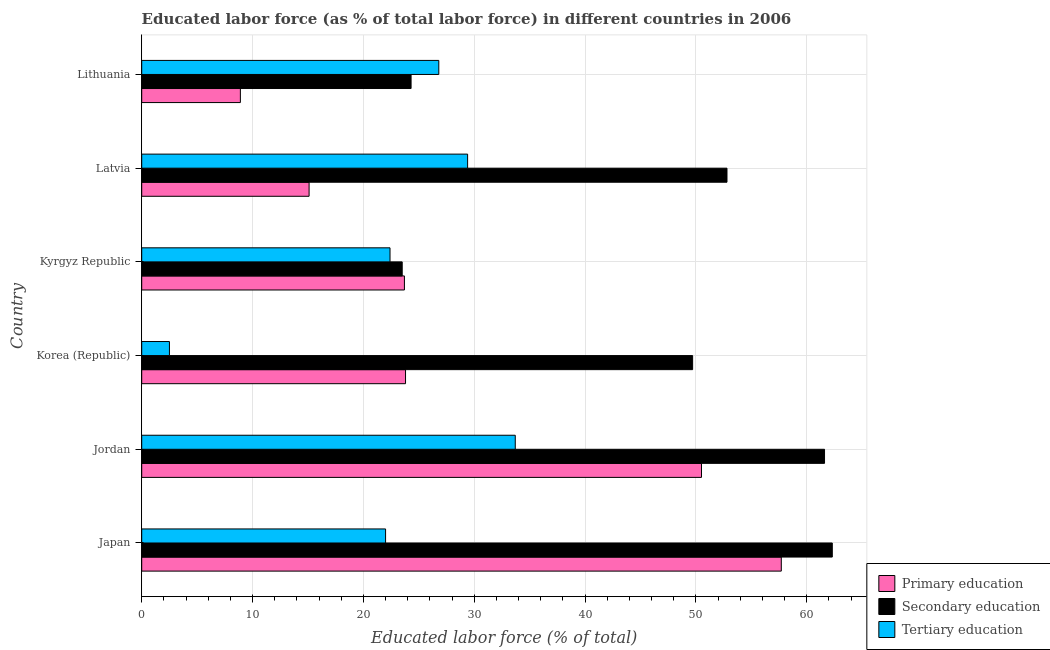How many groups of bars are there?
Make the answer very short. 6. Are the number of bars per tick equal to the number of legend labels?
Offer a very short reply. Yes. What is the percentage of labor force who received primary education in Japan?
Provide a short and direct response. 57.7. Across all countries, what is the maximum percentage of labor force who received secondary education?
Provide a short and direct response. 62.3. In which country was the percentage of labor force who received tertiary education maximum?
Provide a succinct answer. Jordan. In which country was the percentage of labor force who received tertiary education minimum?
Give a very brief answer. Korea (Republic). What is the total percentage of labor force who received primary education in the graph?
Keep it short and to the point. 179.7. What is the difference between the percentage of labor force who received secondary education in Japan and that in Kyrgyz Republic?
Give a very brief answer. 38.8. What is the difference between the percentage of labor force who received tertiary education in Kyrgyz Republic and the percentage of labor force who received primary education in Lithuania?
Offer a very short reply. 13.5. What is the average percentage of labor force who received primary education per country?
Your answer should be compact. 29.95. What is the difference between the percentage of labor force who received tertiary education and percentage of labor force who received primary education in Jordan?
Ensure brevity in your answer.  -16.8. In how many countries, is the percentage of labor force who received primary education greater than 42 %?
Provide a succinct answer. 2. What is the ratio of the percentage of labor force who received tertiary education in Kyrgyz Republic to that in Latvia?
Offer a terse response. 0.76. What is the difference between the highest and the lowest percentage of labor force who received secondary education?
Make the answer very short. 38.8. In how many countries, is the percentage of labor force who received tertiary education greater than the average percentage of labor force who received tertiary education taken over all countries?
Your answer should be very brief. 3. Is the sum of the percentage of labor force who received secondary education in Japan and Korea (Republic) greater than the maximum percentage of labor force who received tertiary education across all countries?
Offer a very short reply. Yes. What does the 2nd bar from the top in Kyrgyz Republic represents?
Keep it short and to the point. Secondary education. What does the 1st bar from the bottom in Japan represents?
Give a very brief answer. Primary education. Is it the case that in every country, the sum of the percentage of labor force who received primary education and percentage of labor force who received secondary education is greater than the percentage of labor force who received tertiary education?
Provide a succinct answer. Yes. How many bars are there?
Make the answer very short. 18. Are all the bars in the graph horizontal?
Make the answer very short. Yes. How many countries are there in the graph?
Provide a succinct answer. 6. What is the difference between two consecutive major ticks on the X-axis?
Offer a terse response. 10. Are the values on the major ticks of X-axis written in scientific E-notation?
Your response must be concise. No. How many legend labels are there?
Offer a very short reply. 3. What is the title of the graph?
Offer a terse response. Educated labor force (as % of total labor force) in different countries in 2006. Does "Agriculture" appear as one of the legend labels in the graph?
Your answer should be compact. No. What is the label or title of the X-axis?
Offer a terse response. Educated labor force (% of total). What is the label or title of the Y-axis?
Offer a terse response. Country. What is the Educated labor force (% of total) of Primary education in Japan?
Provide a short and direct response. 57.7. What is the Educated labor force (% of total) in Secondary education in Japan?
Ensure brevity in your answer.  62.3. What is the Educated labor force (% of total) of Tertiary education in Japan?
Provide a short and direct response. 22. What is the Educated labor force (% of total) in Primary education in Jordan?
Your response must be concise. 50.5. What is the Educated labor force (% of total) in Secondary education in Jordan?
Keep it short and to the point. 61.6. What is the Educated labor force (% of total) in Tertiary education in Jordan?
Your answer should be compact. 33.7. What is the Educated labor force (% of total) of Primary education in Korea (Republic)?
Your response must be concise. 23.8. What is the Educated labor force (% of total) of Secondary education in Korea (Republic)?
Make the answer very short. 49.7. What is the Educated labor force (% of total) of Primary education in Kyrgyz Republic?
Keep it short and to the point. 23.7. What is the Educated labor force (% of total) in Secondary education in Kyrgyz Republic?
Offer a very short reply. 23.5. What is the Educated labor force (% of total) in Tertiary education in Kyrgyz Republic?
Give a very brief answer. 22.4. What is the Educated labor force (% of total) in Primary education in Latvia?
Provide a short and direct response. 15.1. What is the Educated labor force (% of total) of Secondary education in Latvia?
Provide a short and direct response. 52.8. What is the Educated labor force (% of total) in Tertiary education in Latvia?
Your answer should be compact. 29.4. What is the Educated labor force (% of total) in Primary education in Lithuania?
Give a very brief answer. 8.9. What is the Educated labor force (% of total) of Secondary education in Lithuania?
Your answer should be compact. 24.3. What is the Educated labor force (% of total) in Tertiary education in Lithuania?
Your answer should be very brief. 26.8. Across all countries, what is the maximum Educated labor force (% of total) of Primary education?
Your answer should be very brief. 57.7. Across all countries, what is the maximum Educated labor force (% of total) in Secondary education?
Make the answer very short. 62.3. Across all countries, what is the maximum Educated labor force (% of total) in Tertiary education?
Your answer should be very brief. 33.7. Across all countries, what is the minimum Educated labor force (% of total) in Primary education?
Your answer should be compact. 8.9. Across all countries, what is the minimum Educated labor force (% of total) of Secondary education?
Offer a very short reply. 23.5. What is the total Educated labor force (% of total) in Primary education in the graph?
Give a very brief answer. 179.7. What is the total Educated labor force (% of total) of Secondary education in the graph?
Make the answer very short. 274.2. What is the total Educated labor force (% of total) in Tertiary education in the graph?
Your response must be concise. 136.8. What is the difference between the Educated labor force (% of total) of Primary education in Japan and that in Korea (Republic)?
Ensure brevity in your answer.  33.9. What is the difference between the Educated labor force (% of total) in Secondary education in Japan and that in Kyrgyz Republic?
Your answer should be very brief. 38.8. What is the difference between the Educated labor force (% of total) in Primary education in Japan and that in Latvia?
Keep it short and to the point. 42.6. What is the difference between the Educated labor force (% of total) of Tertiary education in Japan and that in Latvia?
Your answer should be compact. -7.4. What is the difference between the Educated labor force (% of total) in Primary education in Japan and that in Lithuania?
Offer a very short reply. 48.8. What is the difference between the Educated labor force (% of total) of Secondary education in Japan and that in Lithuania?
Give a very brief answer. 38. What is the difference between the Educated labor force (% of total) in Primary education in Jordan and that in Korea (Republic)?
Your response must be concise. 26.7. What is the difference between the Educated labor force (% of total) in Secondary education in Jordan and that in Korea (Republic)?
Make the answer very short. 11.9. What is the difference between the Educated labor force (% of total) in Tertiary education in Jordan and that in Korea (Republic)?
Ensure brevity in your answer.  31.2. What is the difference between the Educated labor force (% of total) of Primary education in Jordan and that in Kyrgyz Republic?
Keep it short and to the point. 26.8. What is the difference between the Educated labor force (% of total) in Secondary education in Jordan and that in Kyrgyz Republic?
Keep it short and to the point. 38.1. What is the difference between the Educated labor force (% of total) in Primary education in Jordan and that in Latvia?
Give a very brief answer. 35.4. What is the difference between the Educated labor force (% of total) of Tertiary education in Jordan and that in Latvia?
Give a very brief answer. 4.3. What is the difference between the Educated labor force (% of total) in Primary education in Jordan and that in Lithuania?
Offer a terse response. 41.6. What is the difference between the Educated labor force (% of total) in Secondary education in Jordan and that in Lithuania?
Your answer should be very brief. 37.3. What is the difference between the Educated labor force (% of total) in Tertiary education in Jordan and that in Lithuania?
Your answer should be very brief. 6.9. What is the difference between the Educated labor force (% of total) in Primary education in Korea (Republic) and that in Kyrgyz Republic?
Give a very brief answer. 0.1. What is the difference between the Educated labor force (% of total) in Secondary education in Korea (Republic) and that in Kyrgyz Republic?
Provide a succinct answer. 26.2. What is the difference between the Educated labor force (% of total) of Tertiary education in Korea (Republic) and that in Kyrgyz Republic?
Offer a terse response. -19.9. What is the difference between the Educated labor force (% of total) of Primary education in Korea (Republic) and that in Latvia?
Make the answer very short. 8.7. What is the difference between the Educated labor force (% of total) of Secondary education in Korea (Republic) and that in Latvia?
Your answer should be very brief. -3.1. What is the difference between the Educated labor force (% of total) of Tertiary education in Korea (Republic) and that in Latvia?
Provide a short and direct response. -26.9. What is the difference between the Educated labor force (% of total) in Primary education in Korea (Republic) and that in Lithuania?
Your answer should be compact. 14.9. What is the difference between the Educated labor force (% of total) in Secondary education in Korea (Republic) and that in Lithuania?
Provide a succinct answer. 25.4. What is the difference between the Educated labor force (% of total) in Tertiary education in Korea (Republic) and that in Lithuania?
Keep it short and to the point. -24.3. What is the difference between the Educated labor force (% of total) in Secondary education in Kyrgyz Republic and that in Latvia?
Your answer should be very brief. -29.3. What is the difference between the Educated labor force (% of total) in Tertiary education in Kyrgyz Republic and that in Lithuania?
Make the answer very short. -4.4. What is the difference between the Educated labor force (% of total) of Primary education in Latvia and that in Lithuania?
Provide a short and direct response. 6.2. What is the difference between the Educated labor force (% of total) in Primary education in Japan and the Educated labor force (% of total) in Secondary education in Jordan?
Provide a succinct answer. -3.9. What is the difference between the Educated labor force (% of total) in Secondary education in Japan and the Educated labor force (% of total) in Tertiary education in Jordan?
Ensure brevity in your answer.  28.6. What is the difference between the Educated labor force (% of total) in Primary education in Japan and the Educated labor force (% of total) in Tertiary education in Korea (Republic)?
Offer a very short reply. 55.2. What is the difference between the Educated labor force (% of total) of Secondary education in Japan and the Educated labor force (% of total) of Tertiary education in Korea (Republic)?
Provide a short and direct response. 59.8. What is the difference between the Educated labor force (% of total) in Primary education in Japan and the Educated labor force (% of total) in Secondary education in Kyrgyz Republic?
Your answer should be compact. 34.2. What is the difference between the Educated labor force (% of total) of Primary education in Japan and the Educated labor force (% of total) of Tertiary education in Kyrgyz Republic?
Offer a very short reply. 35.3. What is the difference between the Educated labor force (% of total) in Secondary education in Japan and the Educated labor force (% of total) in Tertiary education in Kyrgyz Republic?
Give a very brief answer. 39.9. What is the difference between the Educated labor force (% of total) of Primary education in Japan and the Educated labor force (% of total) of Tertiary education in Latvia?
Ensure brevity in your answer.  28.3. What is the difference between the Educated labor force (% of total) in Secondary education in Japan and the Educated labor force (% of total) in Tertiary education in Latvia?
Make the answer very short. 32.9. What is the difference between the Educated labor force (% of total) of Primary education in Japan and the Educated labor force (% of total) of Secondary education in Lithuania?
Offer a terse response. 33.4. What is the difference between the Educated labor force (% of total) of Primary education in Japan and the Educated labor force (% of total) of Tertiary education in Lithuania?
Keep it short and to the point. 30.9. What is the difference between the Educated labor force (% of total) of Secondary education in Japan and the Educated labor force (% of total) of Tertiary education in Lithuania?
Offer a terse response. 35.5. What is the difference between the Educated labor force (% of total) in Primary education in Jordan and the Educated labor force (% of total) in Tertiary education in Korea (Republic)?
Ensure brevity in your answer.  48. What is the difference between the Educated labor force (% of total) in Secondary education in Jordan and the Educated labor force (% of total) in Tertiary education in Korea (Republic)?
Provide a succinct answer. 59.1. What is the difference between the Educated labor force (% of total) in Primary education in Jordan and the Educated labor force (% of total) in Secondary education in Kyrgyz Republic?
Provide a succinct answer. 27. What is the difference between the Educated labor force (% of total) in Primary education in Jordan and the Educated labor force (% of total) in Tertiary education in Kyrgyz Republic?
Make the answer very short. 28.1. What is the difference between the Educated labor force (% of total) in Secondary education in Jordan and the Educated labor force (% of total) in Tertiary education in Kyrgyz Republic?
Provide a short and direct response. 39.2. What is the difference between the Educated labor force (% of total) of Primary education in Jordan and the Educated labor force (% of total) of Tertiary education in Latvia?
Offer a terse response. 21.1. What is the difference between the Educated labor force (% of total) of Secondary education in Jordan and the Educated labor force (% of total) of Tertiary education in Latvia?
Offer a very short reply. 32.2. What is the difference between the Educated labor force (% of total) of Primary education in Jordan and the Educated labor force (% of total) of Secondary education in Lithuania?
Keep it short and to the point. 26.2. What is the difference between the Educated labor force (% of total) in Primary education in Jordan and the Educated labor force (% of total) in Tertiary education in Lithuania?
Offer a terse response. 23.7. What is the difference between the Educated labor force (% of total) of Secondary education in Jordan and the Educated labor force (% of total) of Tertiary education in Lithuania?
Your answer should be very brief. 34.8. What is the difference between the Educated labor force (% of total) in Primary education in Korea (Republic) and the Educated labor force (% of total) in Secondary education in Kyrgyz Republic?
Your answer should be very brief. 0.3. What is the difference between the Educated labor force (% of total) of Secondary education in Korea (Republic) and the Educated labor force (% of total) of Tertiary education in Kyrgyz Republic?
Provide a short and direct response. 27.3. What is the difference between the Educated labor force (% of total) in Primary education in Korea (Republic) and the Educated labor force (% of total) in Secondary education in Latvia?
Provide a short and direct response. -29. What is the difference between the Educated labor force (% of total) of Secondary education in Korea (Republic) and the Educated labor force (% of total) of Tertiary education in Latvia?
Offer a terse response. 20.3. What is the difference between the Educated labor force (% of total) of Primary education in Korea (Republic) and the Educated labor force (% of total) of Tertiary education in Lithuania?
Your answer should be very brief. -3. What is the difference between the Educated labor force (% of total) of Secondary education in Korea (Republic) and the Educated labor force (% of total) of Tertiary education in Lithuania?
Offer a terse response. 22.9. What is the difference between the Educated labor force (% of total) of Primary education in Kyrgyz Republic and the Educated labor force (% of total) of Secondary education in Latvia?
Keep it short and to the point. -29.1. What is the difference between the Educated labor force (% of total) of Secondary education in Kyrgyz Republic and the Educated labor force (% of total) of Tertiary education in Latvia?
Ensure brevity in your answer.  -5.9. What is the difference between the Educated labor force (% of total) in Primary education in Kyrgyz Republic and the Educated labor force (% of total) in Secondary education in Lithuania?
Your answer should be compact. -0.6. What is the difference between the Educated labor force (% of total) in Secondary education in Latvia and the Educated labor force (% of total) in Tertiary education in Lithuania?
Offer a terse response. 26. What is the average Educated labor force (% of total) in Primary education per country?
Your response must be concise. 29.95. What is the average Educated labor force (% of total) in Secondary education per country?
Offer a very short reply. 45.7. What is the average Educated labor force (% of total) in Tertiary education per country?
Your answer should be compact. 22.8. What is the difference between the Educated labor force (% of total) of Primary education and Educated labor force (% of total) of Secondary education in Japan?
Provide a succinct answer. -4.6. What is the difference between the Educated labor force (% of total) in Primary education and Educated labor force (% of total) in Tertiary education in Japan?
Provide a succinct answer. 35.7. What is the difference between the Educated labor force (% of total) of Secondary education and Educated labor force (% of total) of Tertiary education in Japan?
Your response must be concise. 40.3. What is the difference between the Educated labor force (% of total) in Primary education and Educated labor force (% of total) in Tertiary education in Jordan?
Keep it short and to the point. 16.8. What is the difference between the Educated labor force (% of total) of Secondary education and Educated labor force (% of total) of Tertiary education in Jordan?
Provide a short and direct response. 27.9. What is the difference between the Educated labor force (% of total) of Primary education and Educated labor force (% of total) of Secondary education in Korea (Republic)?
Offer a very short reply. -25.9. What is the difference between the Educated labor force (% of total) of Primary education and Educated labor force (% of total) of Tertiary education in Korea (Republic)?
Give a very brief answer. 21.3. What is the difference between the Educated labor force (% of total) in Secondary education and Educated labor force (% of total) in Tertiary education in Korea (Republic)?
Provide a short and direct response. 47.2. What is the difference between the Educated labor force (% of total) of Primary education and Educated labor force (% of total) of Secondary education in Latvia?
Ensure brevity in your answer.  -37.7. What is the difference between the Educated labor force (% of total) in Primary education and Educated labor force (% of total) in Tertiary education in Latvia?
Provide a succinct answer. -14.3. What is the difference between the Educated labor force (% of total) in Secondary education and Educated labor force (% of total) in Tertiary education in Latvia?
Provide a succinct answer. 23.4. What is the difference between the Educated labor force (% of total) in Primary education and Educated labor force (% of total) in Secondary education in Lithuania?
Give a very brief answer. -15.4. What is the difference between the Educated labor force (% of total) of Primary education and Educated labor force (% of total) of Tertiary education in Lithuania?
Offer a terse response. -17.9. What is the difference between the Educated labor force (% of total) of Secondary education and Educated labor force (% of total) of Tertiary education in Lithuania?
Make the answer very short. -2.5. What is the ratio of the Educated labor force (% of total) in Primary education in Japan to that in Jordan?
Provide a short and direct response. 1.14. What is the ratio of the Educated labor force (% of total) of Secondary education in Japan to that in Jordan?
Ensure brevity in your answer.  1.01. What is the ratio of the Educated labor force (% of total) in Tertiary education in Japan to that in Jordan?
Your answer should be very brief. 0.65. What is the ratio of the Educated labor force (% of total) of Primary education in Japan to that in Korea (Republic)?
Offer a very short reply. 2.42. What is the ratio of the Educated labor force (% of total) of Secondary education in Japan to that in Korea (Republic)?
Provide a succinct answer. 1.25. What is the ratio of the Educated labor force (% of total) in Primary education in Japan to that in Kyrgyz Republic?
Give a very brief answer. 2.43. What is the ratio of the Educated labor force (% of total) in Secondary education in Japan to that in Kyrgyz Republic?
Your answer should be very brief. 2.65. What is the ratio of the Educated labor force (% of total) in Tertiary education in Japan to that in Kyrgyz Republic?
Keep it short and to the point. 0.98. What is the ratio of the Educated labor force (% of total) of Primary education in Japan to that in Latvia?
Offer a very short reply. 3.82. What is the ratio of the Educated labor force (% of total) of Secondary education in Japan to that in Latvia?
Your answer should be compact. 1.18. What is the ratio of the Educated labor force (% of total) in Tertiary education in Japan to that in Latvia?
Ensure brevity in your answer.  0.75. What is the ratio of the Educated labor force (% of total) in Primary education in Japan to that in Lithuania?
Make the answer very short. 6.48. What is the ratio of the Educated labor force (% of total) of Secondary education in Japan to that in Lithuania?
Provide a succinct answer. 2.56. What is the ratio of the Educated labor force (% of total) of Tertiary education in Japan to that in Lithuania?
Your response must be concise. 0.82. What is the ratio of the Educated labor force (% of total) of Primary education in Jordan to that in Korea (Republic)?
Give a very brief answer. 2.12. What is the ratio of the Educated labor force (% of total) in Secondary education in Jordan to that in Korea (Republic)?
Your answer should be compact. 1.24. What is the ratio of the Educated labor force (% of total) in Tertiary education in Jordan to that in Korea (Republic)?
Provide a short and direct response. 13.48. What is the ratio of the Educated labor force (% of total) of Primary education in Jordan to that in Kyrgyz Republic?
Offer a very short reply. 2.13. What is the ratio of the Educated labor force (% of total) of Secondary education in Jordan to that in Kyrgyz Republic?
Keep it short and to the point. 2.62. What is the ratio of the Educated labor force (% of total) in Tertiary education in Jordan to that in Kyrgyz Republic?
Offer a very short reply. 1.5. What is the ratio of the Educated labor force (% of total) of Primary education in Jordan to that in Latvia?
Your response must be concise. 3.34. What is the ratio of the Educated labor force (% of total) of Tertiary education in Jordan to that in Latvia?
Provide a succinct answer. 1.15. What is the ratio of the Educated labor force (% of total) in Primary education in Jordan to that in Lithuania?
Ensure brevity in your answer.  5.67. What is the ratio of the Educated labor force (% of total) of Secondary education in Jordan to that in Lithuania?
Your answer should be compact. 2.54. What is the ratio of the Educated labor force (% of total) in Tertiary education in Jordan to that in Lithuania?
Give a very brief answer. 1.26. What is the ratio of the Educated labor force (% of total) of Secondary education in Korea (Republic) to that in Kyrgyz Republic?
Your response must be concise. 2.11. What is the ratio of the Educated labor force (% of total) of Tertiary education in Korea (Republic) to that in Kyrgyz Republic?
Ensure brevity in your answer.  0.11. What is the ratio of the Educated labor force (% of total) in Primary education in Korea (Republic) to that in Latvia?
Your answer should be compact. 1.58. What is the ratio of the Educated labor force (% of total) in Secondary education in Korea (Republic) to that in Latvia?
Give a very brief answer. 0.94. What is the ratio of the Educated labor force (% of total) in Tertiary education in Korea (Republic) to that in Latvia?
Ensure brevity in your answer.  0.09. What is the ratio of the Educated labor force (% of total) in Primary education in Korea (Republic) to that in Lithuania?
Keep it short and to the point. 2.67. What is the ratio of the Educated labor force (% of total) in Secondary education in Korea (Republic) to that in Lithuania?
Your answer should be very brief. 2.05. What is the ratio of the Educated labor force (% of total) of Tertiary education in Korea (Republic) to that in Lithuania?
Your answer should be very brief. 0.09. What is the ratio of the Educated labor force (% of total) in Primary education in Kyrgyz Republic to that in Latvia?
Make the answer very short. 1.57. What is the ratio of the Educated labor force (% of total) in Secondary education in Kyrgyz Republic to that in Latvia?
Offer a very short reply. 0.45. What is the ratio of the Educated labor force (% of total) of Tertiary education in Kyrgyz Republic to that in Latvia?
Provide a succinct answer. 0.76. What is the ratio of the Educated labor force (% of total) of Primary education in Kyrgyz Republic to that in Lithuania?
Give a very brief answer. 2.66. What is the ratio of the Educated labor force (% of total) in Secondary education in Kyrgyz Republic to that in Lithuania?
Offer a very short reply. 0.97. What is the ratio of the Educated labor force (% of total) in Tertiary education in Kyrgyz Republic to that in Lithuania?
Provide a succinct answer. 0.84. What is the ratio of the Educated labor force (% of total) in Primary education in Latvia to that in Lithuania?
Provide a succinct answer. 1.7. What is the ratio of the Educated labor force (% of total) in Secondary education in Latvia to that in Lithuania?
Give a very brief answer. 2.17. What is the ratio of the Educated labor force (% of total) of Tertiary education in Latvia to that in Lithuania?
Keep it short and to the point. 1.1. What is the difference between the highest and the second highest Educated labor force (% of total) of Tertiary education?
Make the answer very short. 4.3. What is the difference between the highest and the lowest Educated labor force (% of total) in Primary education?
Provide a succinct answer. 48.8. What is the difference between the highest and the lowest Educated labor force (% of total) of Secondary education?
Ensure brevity in your answer.  38.8. What is the difference between the highest and the lowest Educated labor force (% of total) in Tertiary education?
Ensure brevity in your answer.  31.2. 